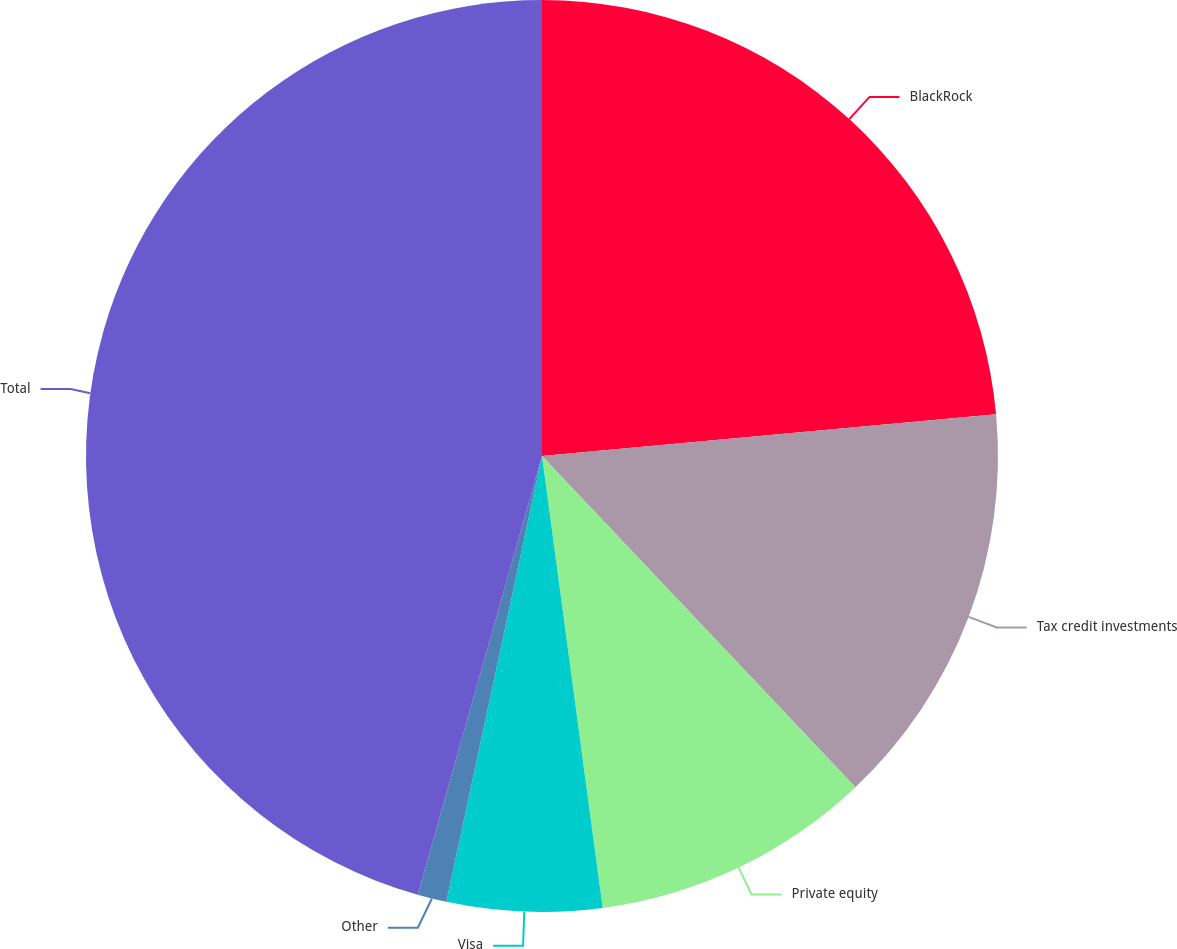Convert chart to OTSL. <chart><loc_0><loc_0><loc_500><loc_500><pie_chart><fcel>BlackRock<fcel>Tax credit investments<fcel>Private equity<fcel>Visa<fcel>Other<fcel>Total<nl><fcel>23.54%<fcel>14.4%<fcel>9.94%<fcel>5.49%<fcel>1.03%<fcel>45.61%<nl></chart> 